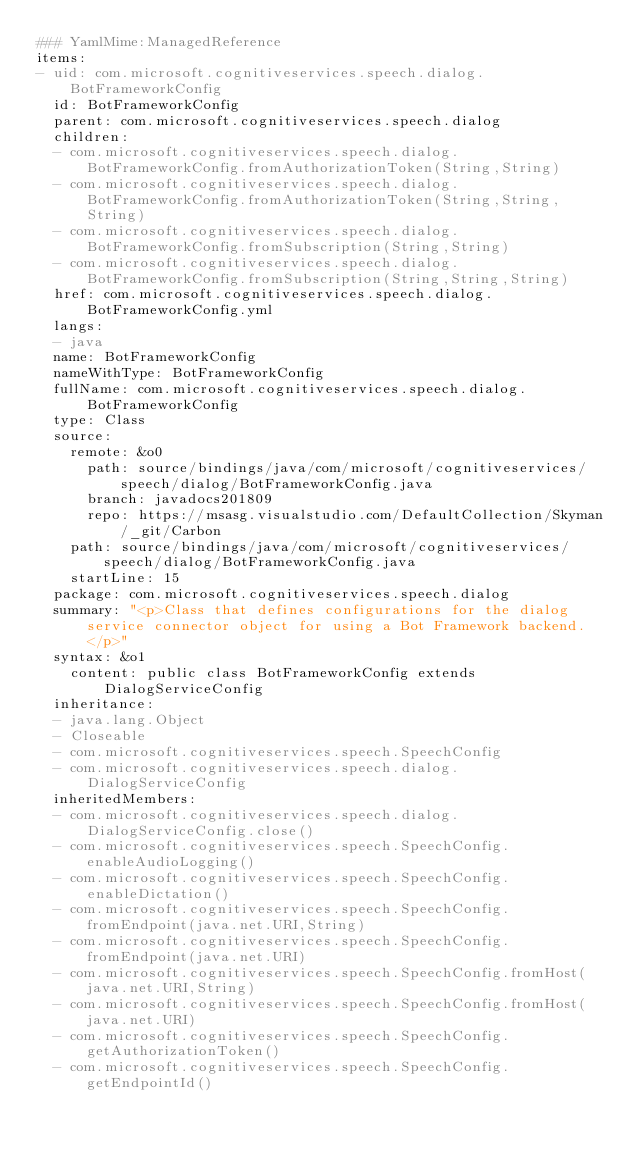<code> <loc_0><loc_0><loc_500><loc_500><_YAML_>### YamlMime:ManagedReference
items:
- uid: com.microsoft.cognitiveservices.speech.dialog.BotFrameworkConfig
  id: BotFrameworkConfig
  parent: com.microsoft.cognitiveservices.speech.dialog
  children:
  - com.microsoft.cognitiveservices.speech.dialog.BotFrameworkConfig.fromAuthorizationToken(String,String)
  - com.microsoft.cognitiveservices.speech.dialog.BotFrameworkConfig.fromAuthorizationToken(String,String,String)
  - com.microsoft.cognitiveservices.speech.dialog.BotFrameworkConfig.fromSubscription(String,String)
  - com.microsoft.cognitiveservices.speech.dialog.BotFrameworkConfig.fromSubscription(String,String,String)
  href: com.microsoft.cognitiveservices.speech.dialog.BotFrameworkConfig.yml
  langs:
  - java
  name: BotFrameworkConfig
  nameWithType: BotFrameworkConfig
  fullName: com.microsoft.cognitiveservices.speech.dialog.BotFrameworkConfig
  type: Class
  source:
    remote: &o0
      path: source/bindings/java/com/microsoft/cognitiveservices/speech/dialog/BotFrameworkConfig.java
      branch: javadocs201809
      repo: https://msasg.visualstudio.com/DefaultCollection/Skyman/_git/Carbon
    path: source/bindings/java/com/microsoft/cognitiveservices/speech/dialog/BotFrameworkConfig.java
    startLine: 15
  package: com.microsoft.cognitiveservices.speech.dialog
  summary: "<p>Class that defines configurations for the dialog service connector object for using a Bot Framework backend. </p>"
  syntax: &o1
    content: public class BotFrameworkConfig extends DialogServiceConfig
  inheritance:
  - java.lang.Object
  - Closeable
  - com.microsoft.cognitiveservices.speech.SpeechConfig
  - com.microsoft.cognitiveservices.speech.dialog.DialogServiceConfig
  inheritedMembers:
  - com.microsoft.cognitiveservices.speech.dialog.DialogServiceConfig.close()
  - com.microsoft.cognitiveservices.speech.SpeechConfig.enableAudioLogging()
  - com.microsoft.cognitiveservices.speech.SpeechConfig.enableDictation()
  - com.microsoft.cognitiveservices.speech.SpeechConfig.fromEndpoint(java.net.URI,String)
  - com.microsoft.cognitiveservices.speech.SpeechConfig.fromEndpoint(java.net.URI)
  - com.microsoft.cognitiveservices.speech.SpeechConfig.fromHost(java.net.URI,String)
  - com.microsoft.cognitiveservices.speech.SpeechConfig.fromHost(java.net.URI)
  - com.microsoft.cognitiveservices.speech.SpeechConfig.getAuthorizationToken()
  - com.microsoft.cognitiveservices.speech.SpeechConfig.getEndpointId()</code> 